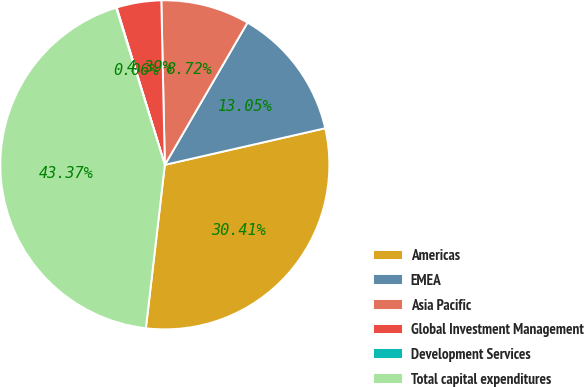Convert chart to OTSL. <chart><loc_0><loc_0><loc_500><loc_500><pie_chart><fcel>Americas<fcel>EMEA<fcel>Asia Pacific<fcel>Global Investment Management<fcel>Development Services<fcel>Total capital expenditures<nl><fcel>30.41%<fcel>13.05%<fcel>8.72%<fcel>4.39%<fcel>0.06%<fcel>43.37%<nl></chart> 